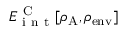Convert formula to latex. <formula><loc_0><loc_0><loc_500><loc_500>E _ { i n t } ^ { C } [ \rho _ { A } , \rho _ { e n v } ]</formula> 